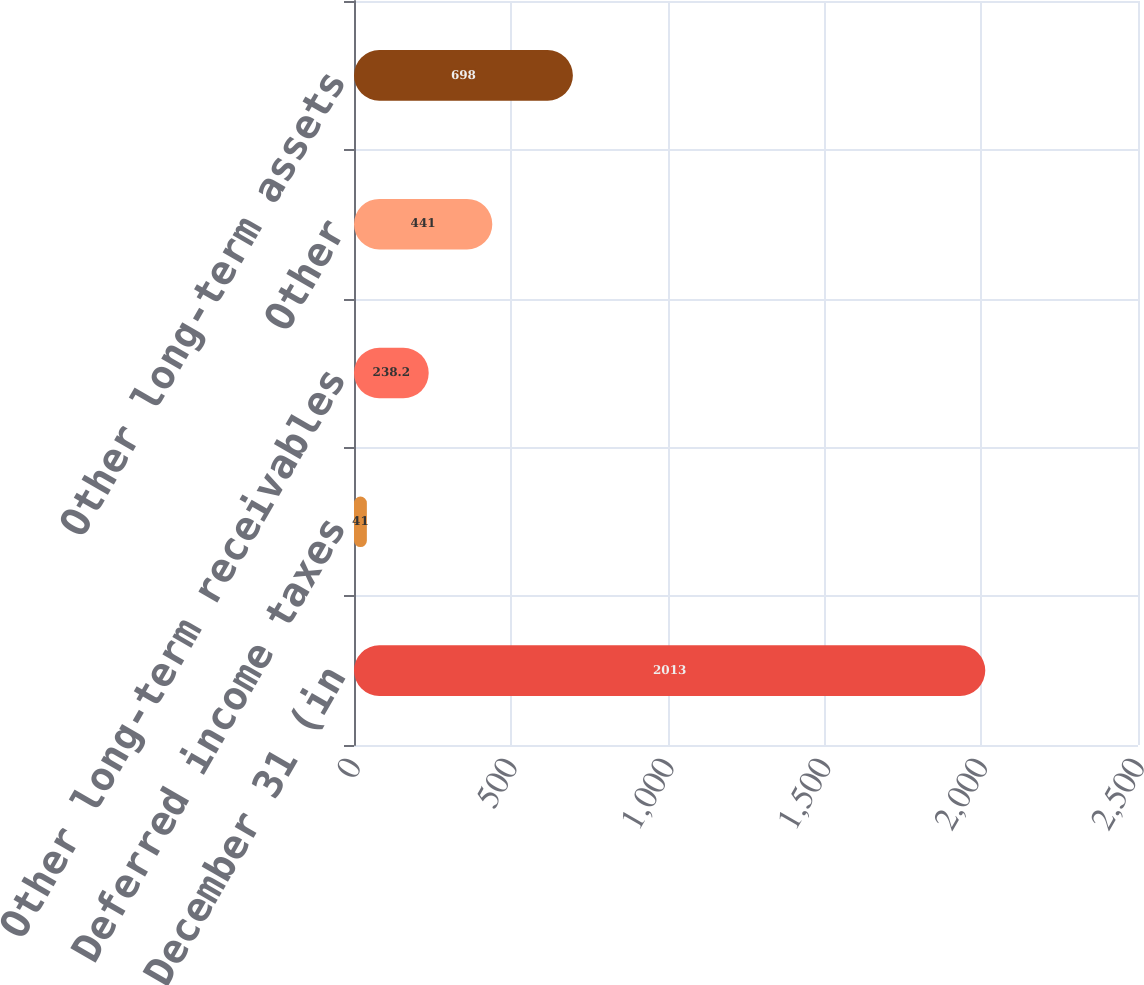Convert chart to OTSL. <chart><loc_0><loc_0><loc_500><loc_500><bar_chart><fcel>as of December 31 (in<fcel>Deferred income taxes<fcel>Other long-term receivables<fcel>Other<fcel>Other long-term assets<nl><fcel>2013<fcel>41<fcel>238.2<fcel>441<fcel>698<nl></chart> 